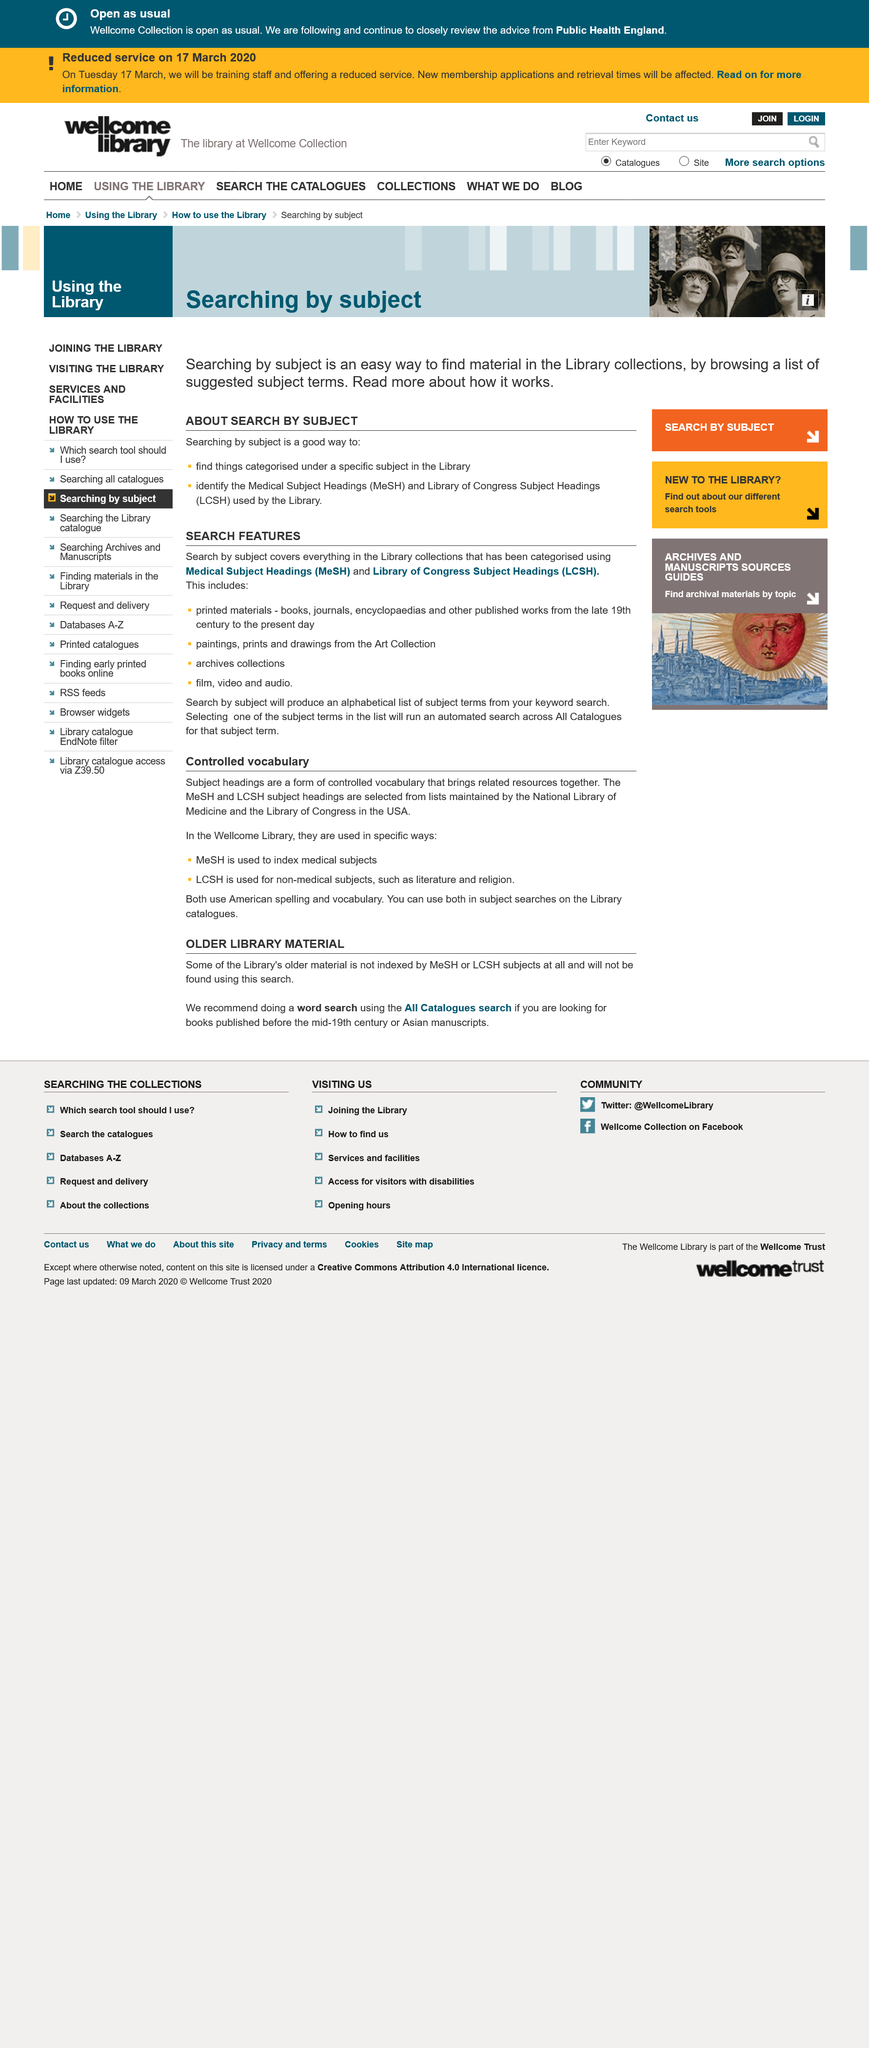List a handful of essential elements in this visual. MeSH is utilized for indexing medical subjects, enabling efficient retrieval and organization of relevant information. LCSH is used for non-medical subjects, such as literature and religion, to provide standardized access points for library catalogs and databases. Subject headings are a form of controlled vocabulary that is used to categorize and organize library resources, bringing related materials together. 